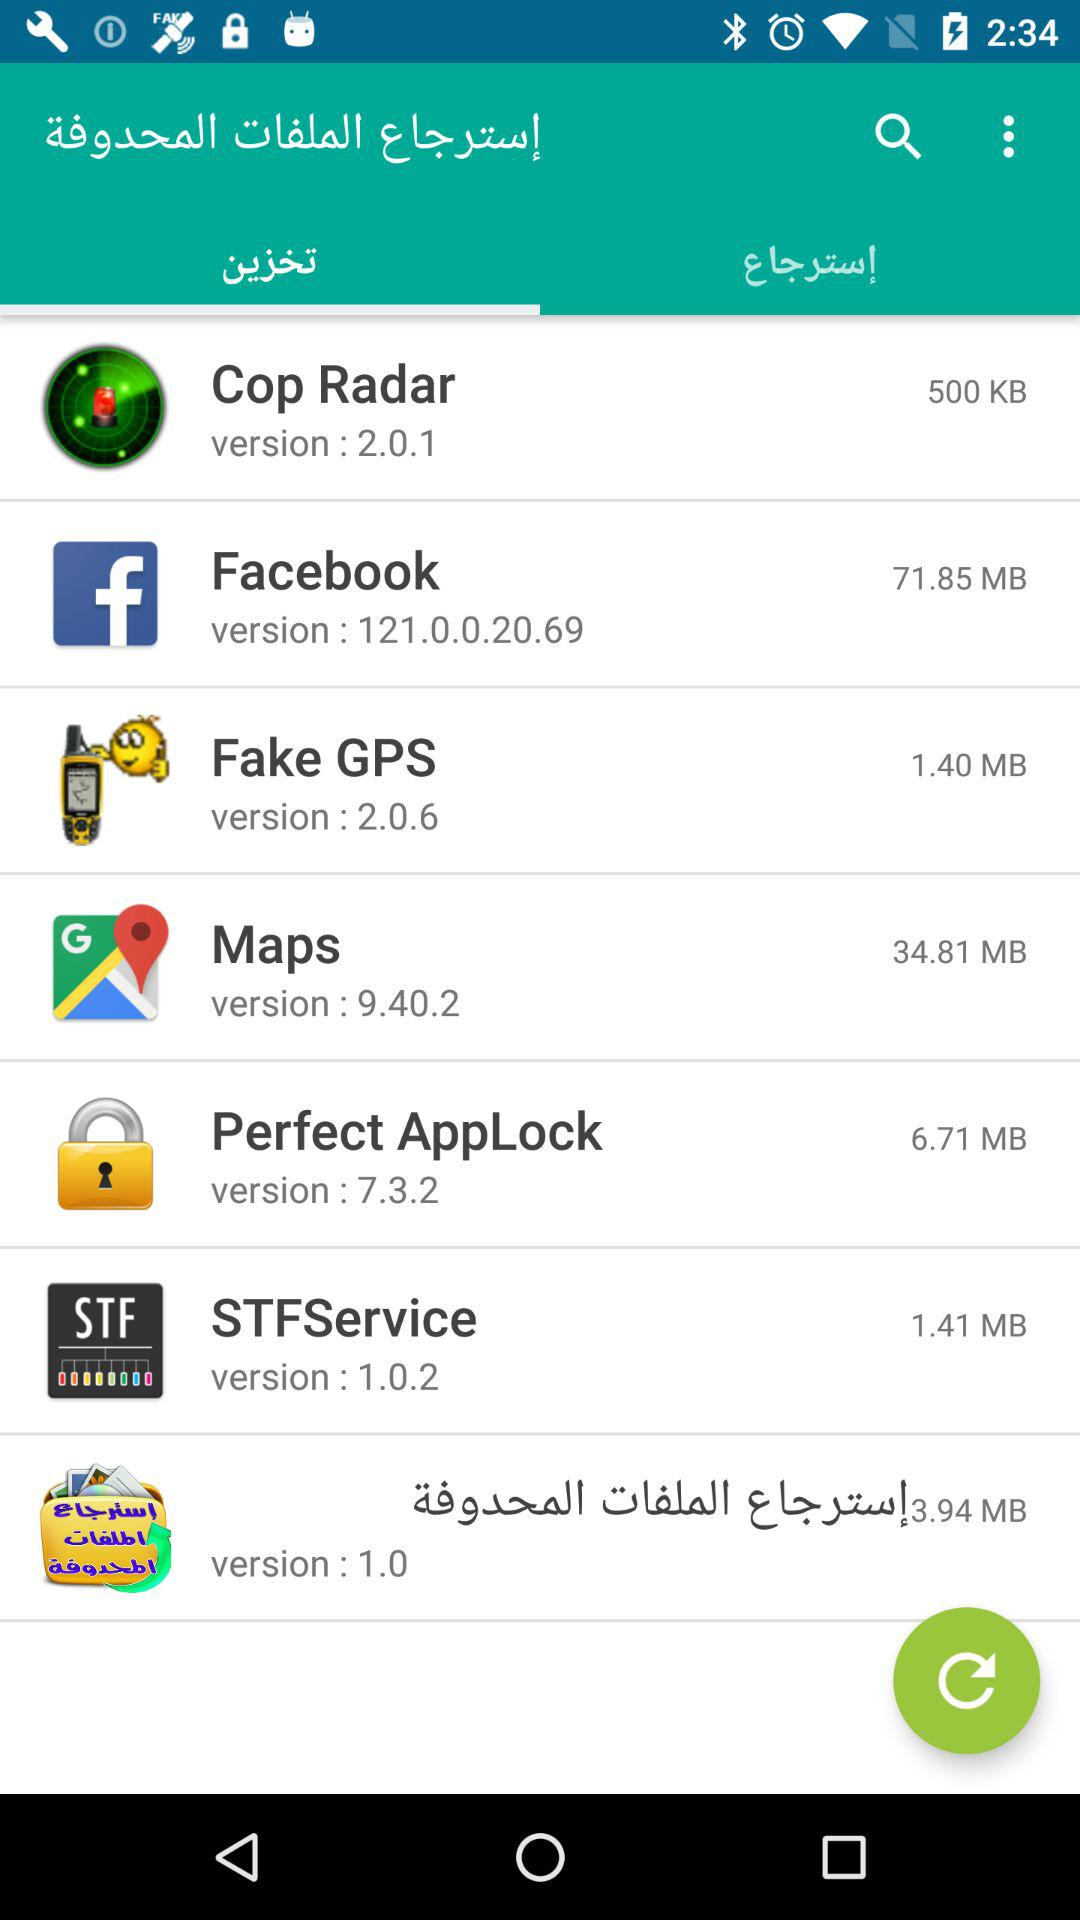What is the version of Facebook? The version of Facebook is 121.0.0.20.69. 